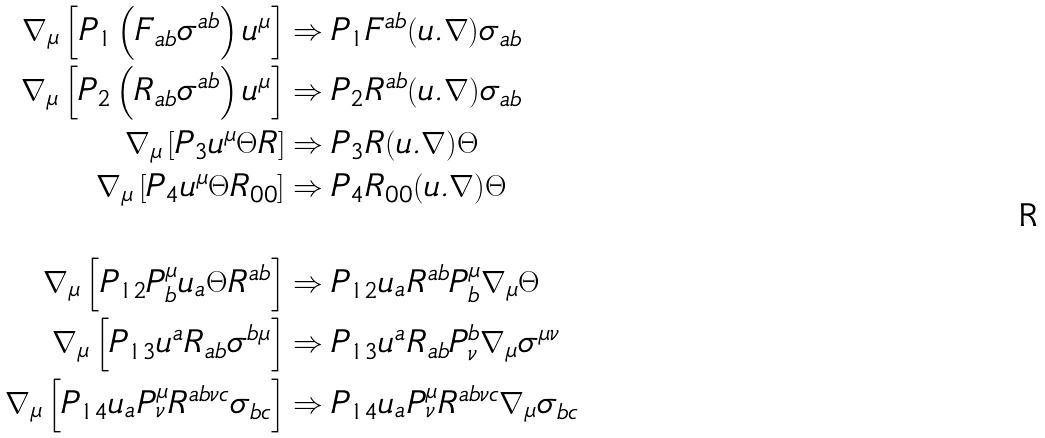Convert formula to latex. <formula><loc_0><loc_0><loc_500><loc_500>\nabla _ { \mu } \left [ P _ { 1 } \left ( F _ { a b } \sigma ^ { a b } \right ) u ^ { \mu } \right ] & \Rightarrow P _ { 1 } F ^ { a b } ( u . \nabla ) \sigma _ { a b } \\ \nabla _ { \mu } \left [ P _ { 2 } \left ( R _ { a b } \sigma ^ { a b } \right ) u ^ { \mu } \right ] & \Rightarrow P _ { 2 } R ^ { a b } ( u . \nabla ) \sigma _ { a b } \\ \nabla _ { \mu } \left [ P _ { 3 } u ^ { \mu } \Theta R \right ] & \Rightarrow P _ { 3 } R ( u . \nabla ) \Theta \\ \nabla _ { \mu } \left [ P _ { 4 } u ^ { \mu } \Theta R _ { 0 0 } \right ] & \Rightarrow P _ { 4 } R _ { 0 0 } ( u . \nabla ) \Theta \\ \\ \nabla _ { \mu } \left [ P _ { 1 2 } P ^ { \mu } _ { b } u _ { a } \Theta R ^ { a b } \right ] & \Rightarrow P _ { 1 2 } u _ { a } R ^ { a b } P ^ { \mu } _ { b } \nabla _ { \mu } \Theta \\ \nabla _ { \mu } \left [ P _ { 1 3 } u ^ { a } R _ { a b } \sigma ^ { b \mu } \right ] & \Rightarrow P _ { 1 3 } u ^ { a } R _ { a b } P _ { \nu } ^ { b } \nabla _ { \mu } \sigma ^ { \mu \nu } \\ \nabla _ { \mu } \left [ P _ { 1 4 } u _ { a } P ^ { \mu } _ { \nu } R ^ { a b \nu c } \sigma _ { b c } \right ] & \Rightarrow P _ { 1 4 } u _ { a } P ^ { \mu } _ { \nu } R ^ { a b \nu c } \nabla _ { \mu } \sigma _ { b c }</formula> 